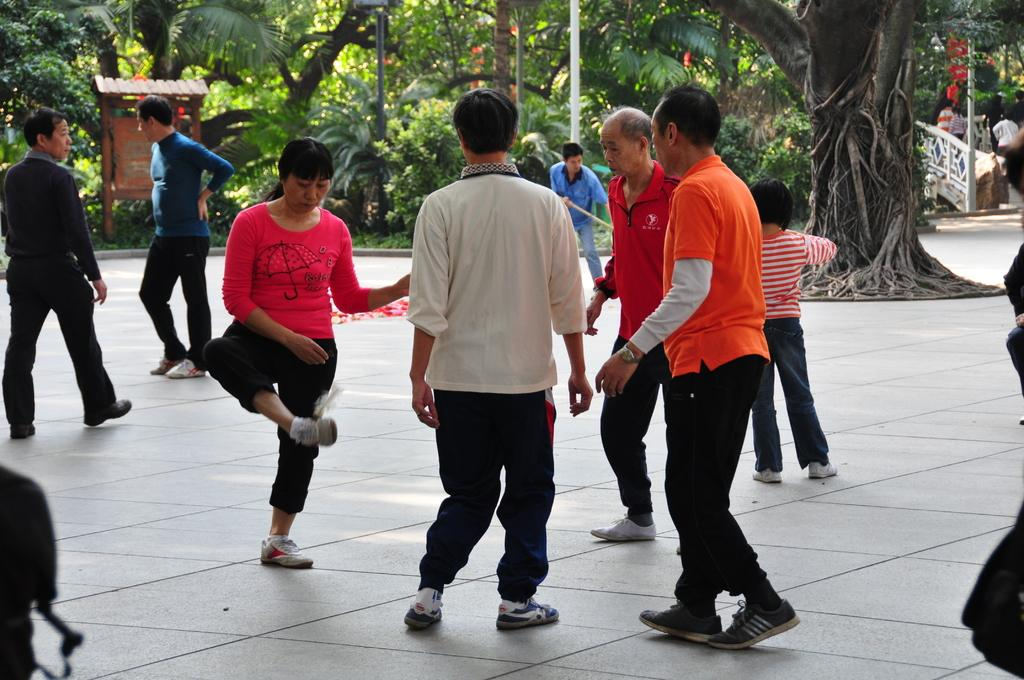What are the people in the image doing? The people in the image are playing on the ground. What can be seen in the background of the image? There are trees and plants in the background of the image. What type of meat is being served at the meeting in the image? There is no meeting or meat present in the image; it features people playing on the ground with trees and plants in the background. 